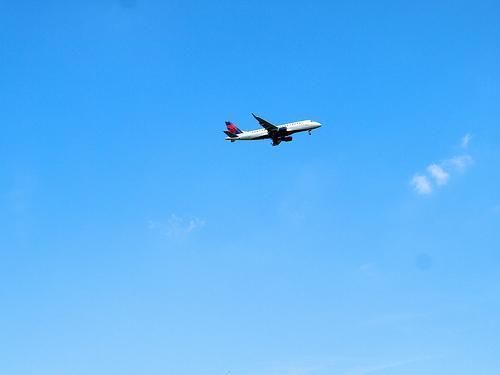How many silhouettes of wheels are clearly visible?
Give a very brief answer. 1. 